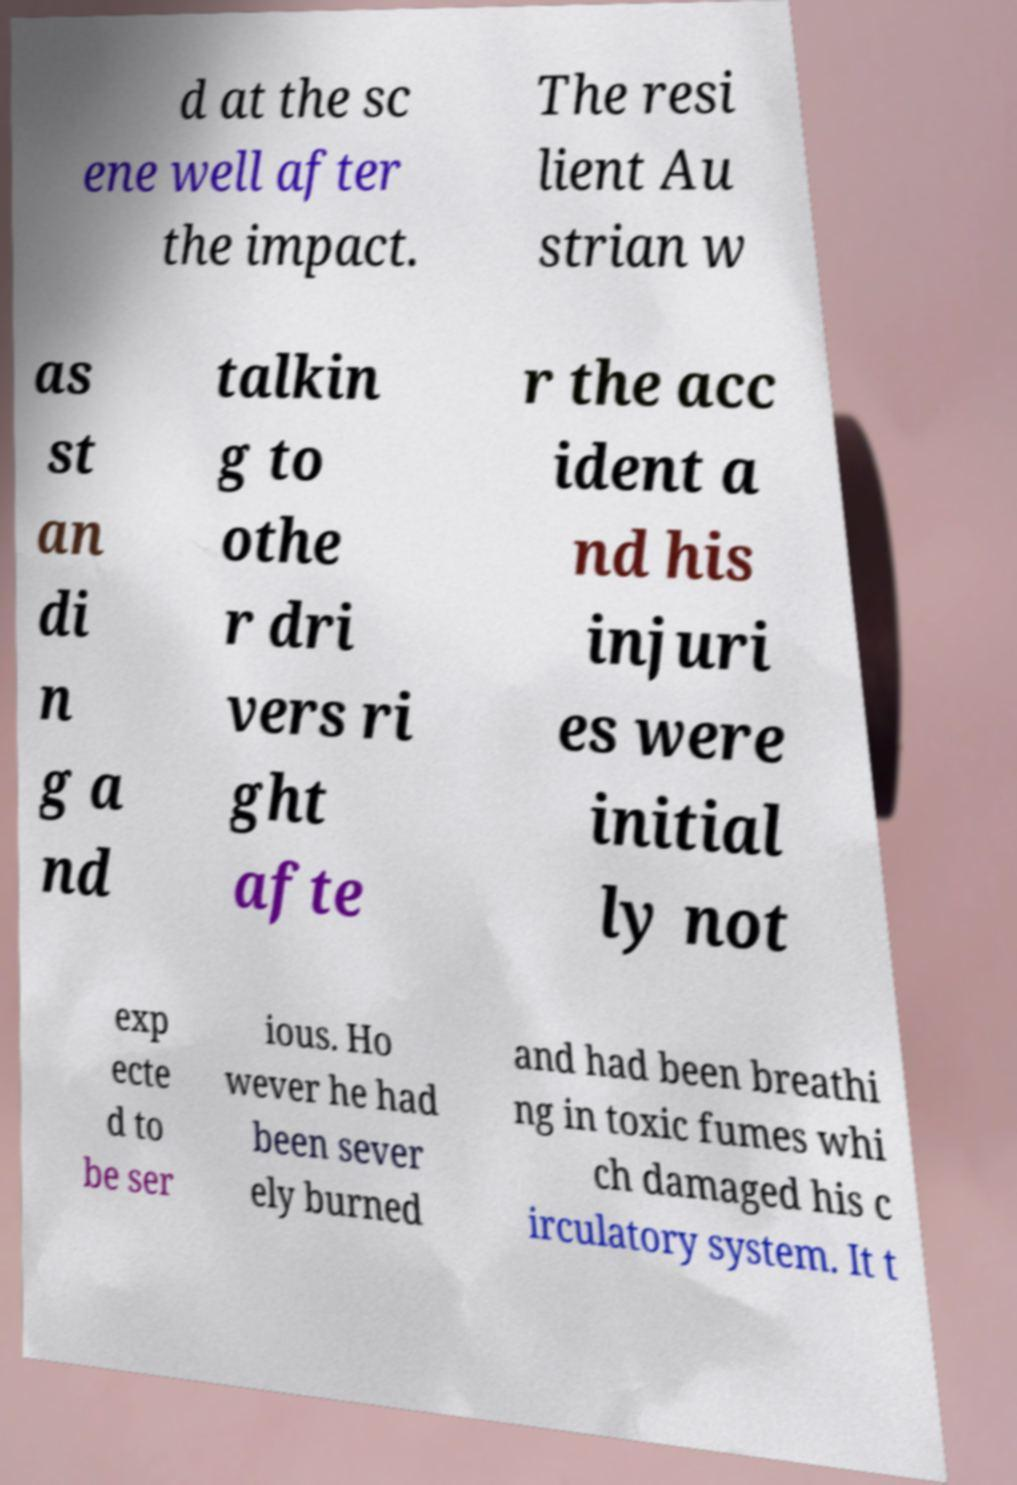There's text embedded in this image that I need extracted. Can you transcribe it verbatim? d at the sc ene well after the impact. The resi lient Au strian w as st an di n g a nd talkin g to othe r dri vers ri ght afte r the acc ident a nd his injuri es were initial ly not exp ecte d to be ser ious. Ho wever he had been sever ely burned and had been breathi ng in toxic fumes whi ch damaged his c irculatory system. It t 